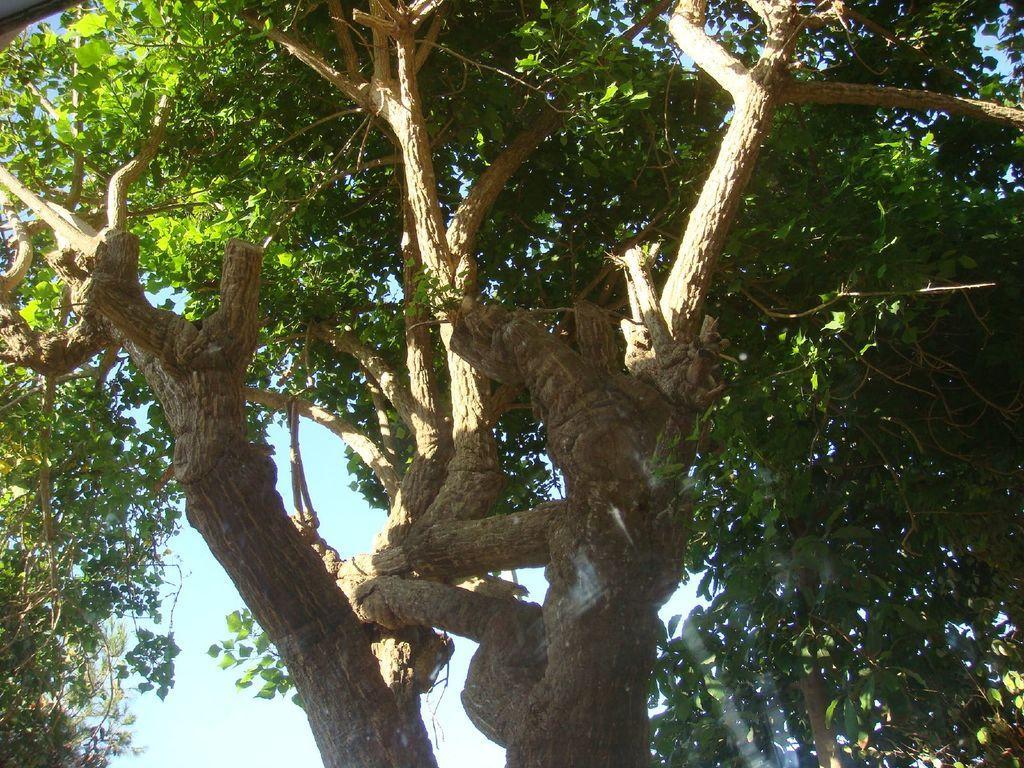Can you describe this image briefly? In this image we can see trees and the sky in the background. 